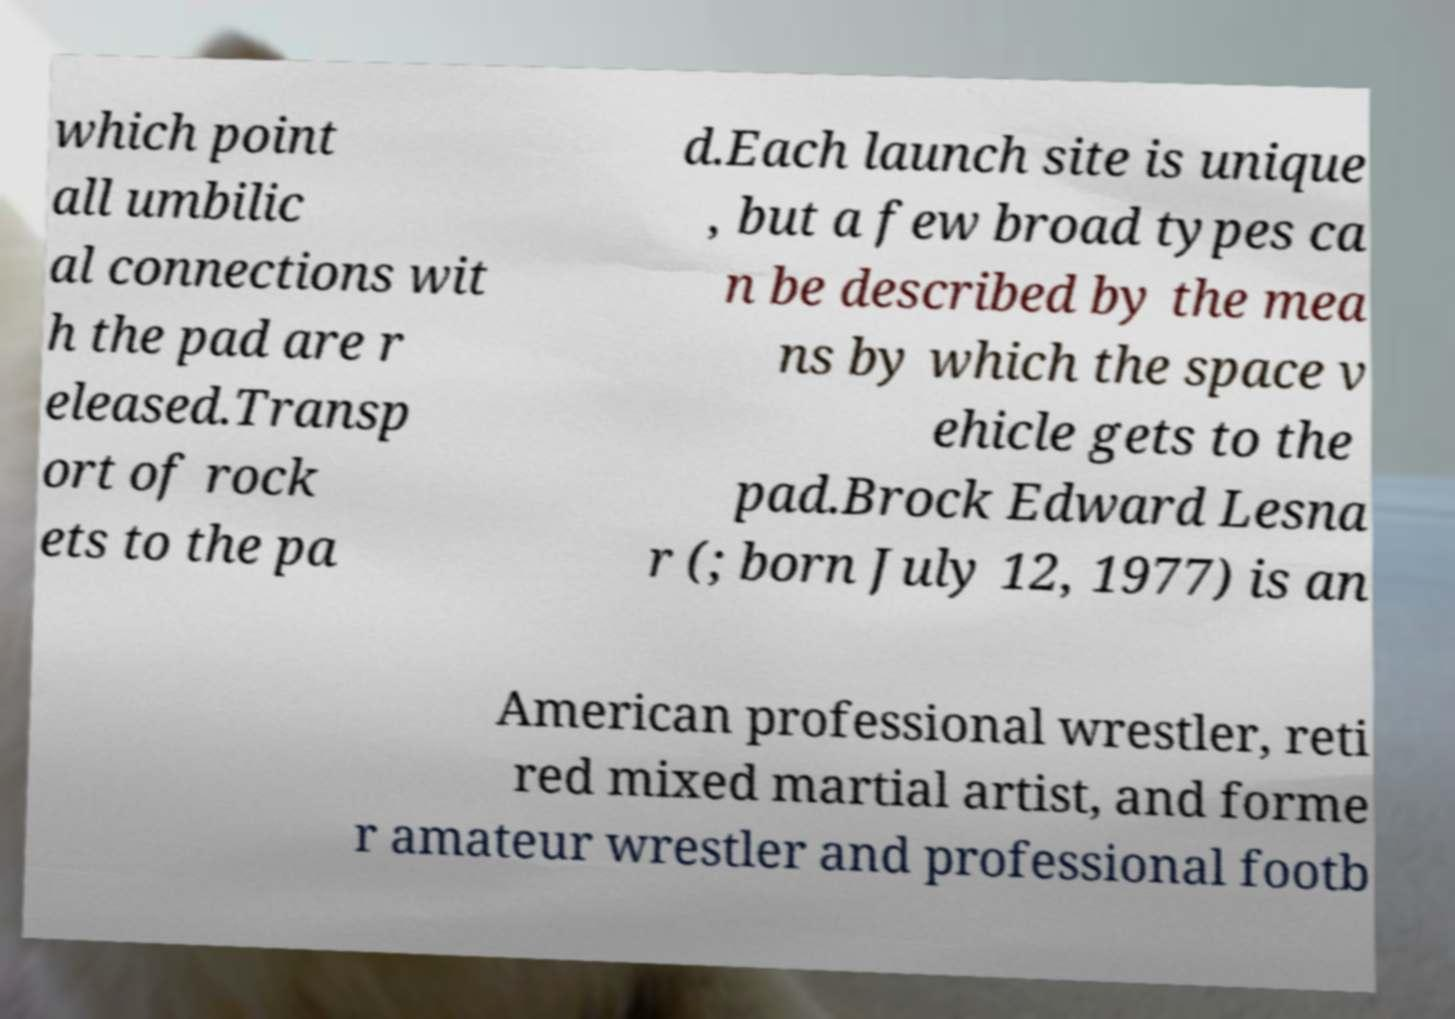Please read and relay the text visible in this image. What does it say? which point all umbilic al connections wit h the pad are r eleased.Transp ort of rock ets to the pa d.Each launch site is unique , but a few broad types ca n be described by the mea ns by which the space v ehicle gets to the pad.Brock Edward Lesna r (; born July 12, 1977) is an American professional wrestler, reti red mixed martial artist, and forme r amateur wrestler and professional footb 